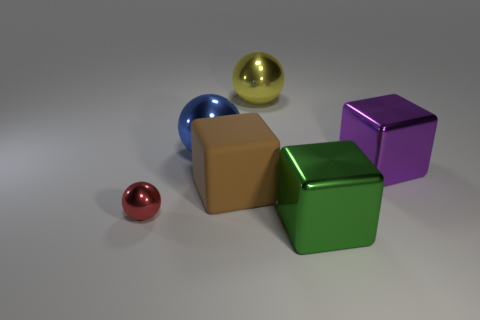Is the tiny metallic object the same color as the big rubber thing?
Provide a short and direct response. No. How many objects are things to the left of the large green metal block or large gray blocks?
Make the answer very short. 4. There is a large metallic block that is left of the large block on the right side of the metal cube that is in front of the purple object; what is its color?
Give a very brief answer. Green. What is the color of the big block that is made of the same material as the green object?
Keep it short and to the point. Purple. What number of yellow things are the same material as the green object?
Ensure brevity in your answer.  1. Does the metal cube behind the red metallic ball have the same size as the tiny sphere?
Offer a very short reply. No. The matte block that is the same size as the yellow object is what color?
Make the answer very short. Brown. There is a yellow thing; what number of big yellow metal things are in front of it?
Offer a very short reply. 0. Are there any small cyan metal things?
Provide a short and direct response. No. What size is the metal block that is behind the big metallic cube that is on the left side of the block behind the big brown block?
Offer a very short reply. Large. 